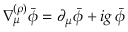<formula> <loc_0><loc_0><loc_500><loc_500>\nabla _ { \mu } ^ { ( \rho ) } \bar { \phi } = \partial _ { \mu } \bar { \phi } + i g \, \bar { \phi }</formula> 